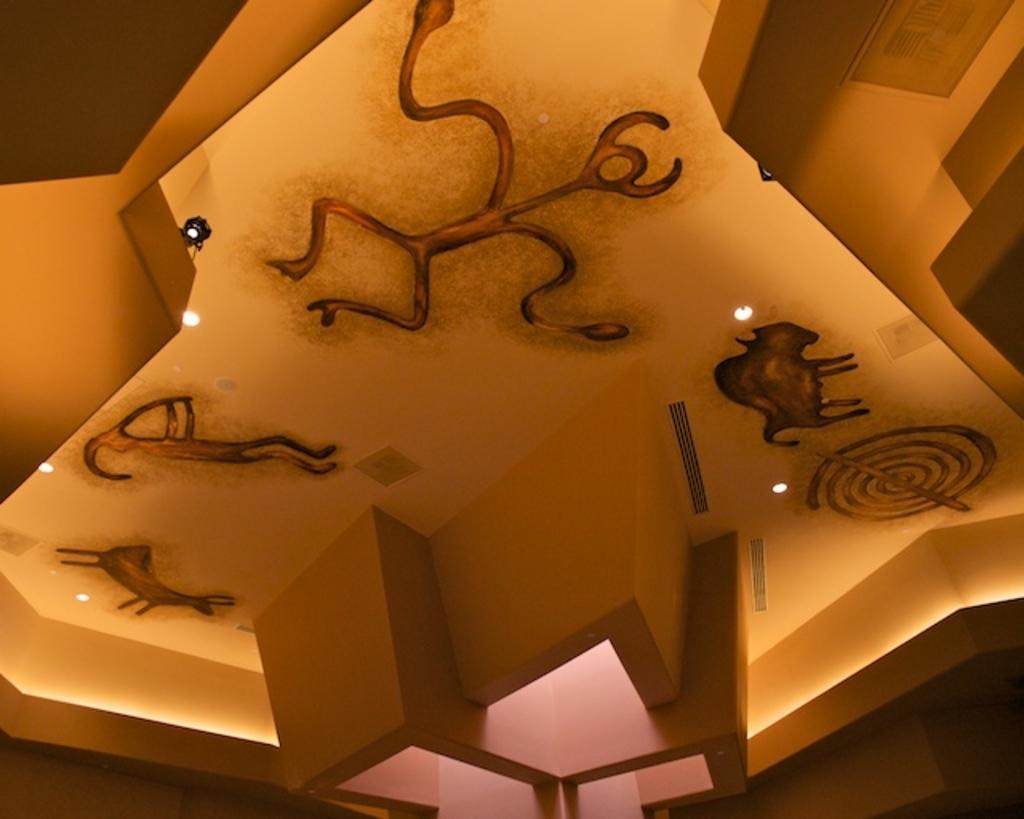How would you summarize this image in a sentence or two? In this picture we can see the designer ceiling, lights and air ducts. 